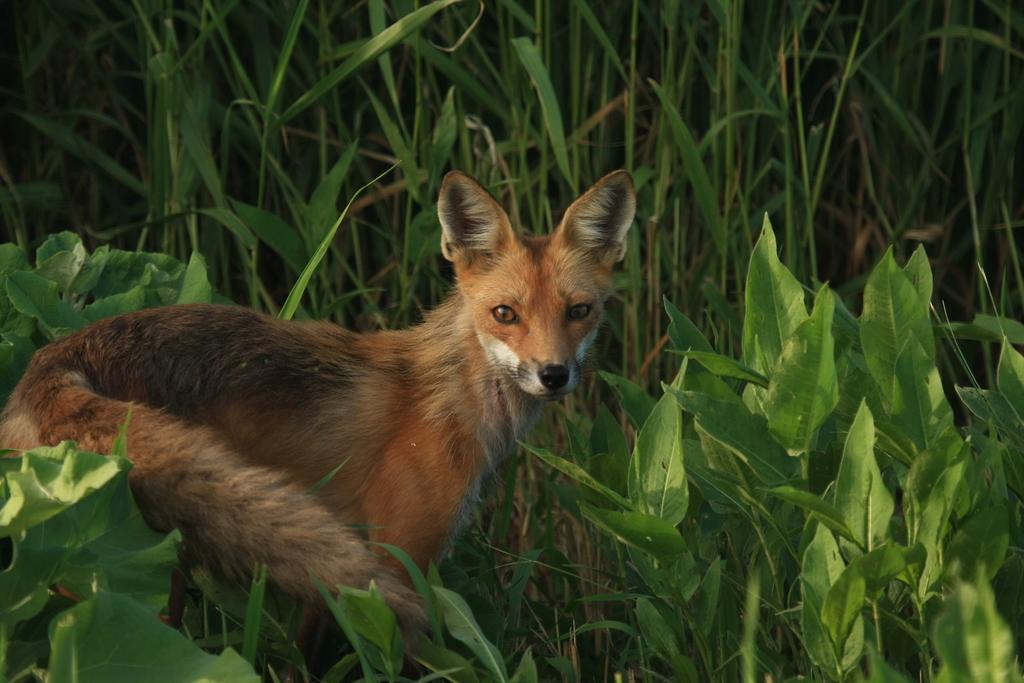How would you summarize this image in a sentence or two? At the bottom we can see plants. On the left side there is a fox standing on the ground. In the background there are plants. 